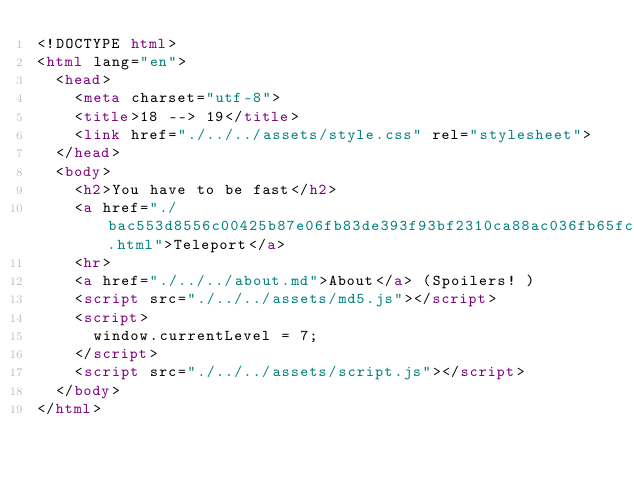Convert code to text. <code><loc_0><loc_0><loc_500><loc_500><_HTML_><!DOCTYPE html>
<html lang="en">
  <head>
    <meta charset="utf-8">
    <title>18 --> 19</title>
    <link href="./../../assets/style.css" rel="stylesheet">
  </head>
  <body>
    <h2>You have to be fast</h2>
    <a href="./bac553d8556c00425b87e06fb83de393f93bf2310ca88ac036fb65fc87e953bf.html">Teleport</a>
    <hr>
    <a href="./../../about.md">About</a> (Spoilers! )
    <script src="./../../assets/md5.js"></script>
    <script>
      window.currentLevel = 7;
    </script>
    <script src="./../../assets/script.js"></script>
  </body>
</html></code> 